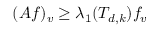<formula> <loc_0><loc_0><loc_500><loc_500>( A f ) _ { v } \geq \lambda _ { 1 } ( T _ { d , k } ) f _ { v }</formula> 